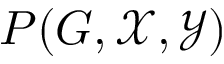Convert formula to latex. <formula><loc_0><loc_0><loc_500><loc_500>P ( G , { \mathcal { X } } , { \mathcal { Y } } )</formula> 